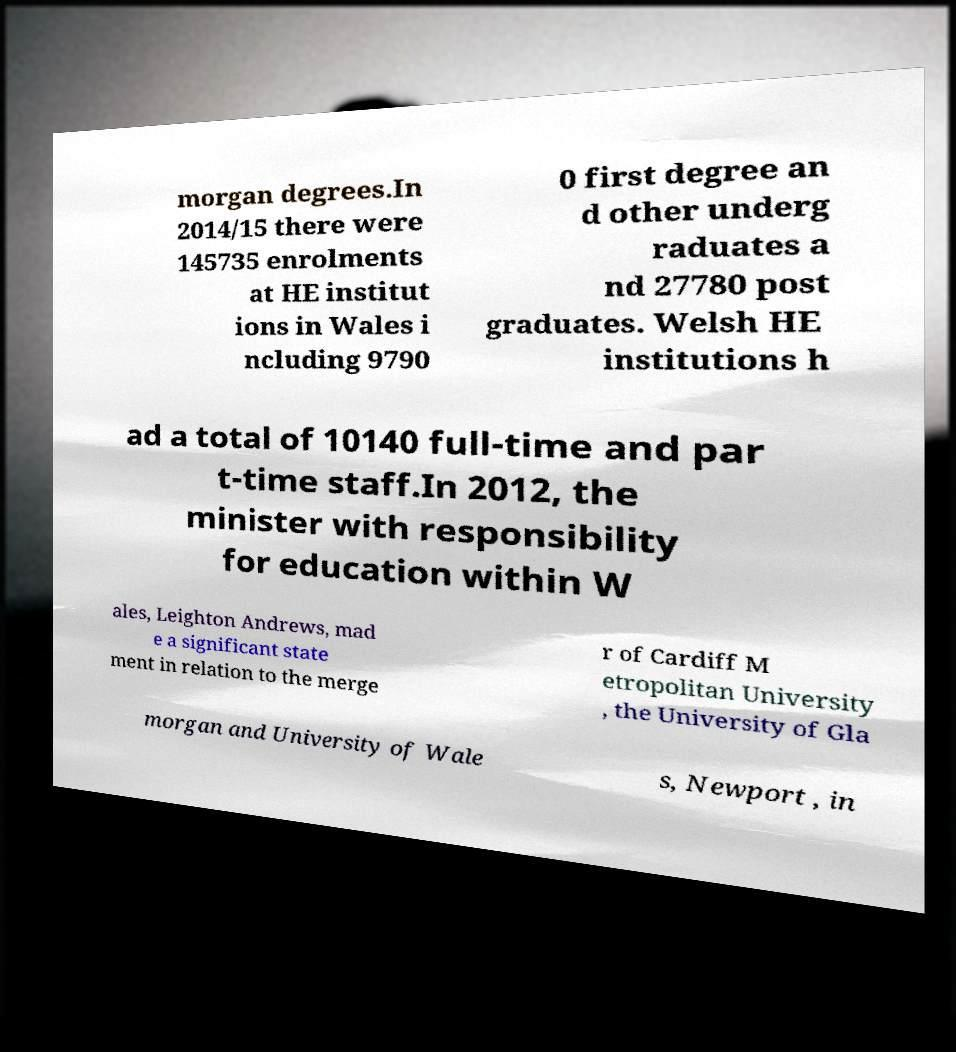Please read and relay the text visible in this image. What does it say? morgan degrees.In 2014/15 there were 145735 enrolments at HE institut ions in Wales i ncluding 9790 0 first degree an d other underg raduates a nd 27780 post graduates. Welsh HE institutions h ad a total of 10140 full-time and par t-time staff.In 2012, the minister with responsibility for education within W ales, Leighton Andrews, mad e a significant state ment in relation to the merge r of Cardiff M etropolitan University , the University of Gla morgan and University of Wale s, Newport , in 